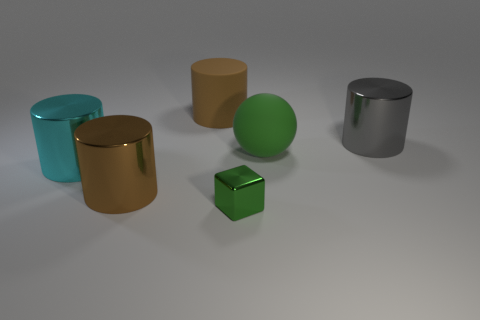Add 1 green metal cubes. How many objects exist? 7 Subtract all cylinders. How many objects are left? 2 Add 2 tiny objects. How many tiny objects are left? 3 Add 5 big brown cylinders. How many big brown cylinders exist? 7 Subtract 1 green spheres. How many objects are left? 5 Subtract all big brown spheres. Subtract all small green blocks. How many objects are left? 5 